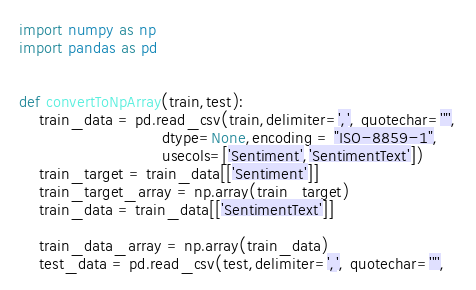<code> <loc_0><loc_0><loc_500><loc_500><_Python_>import numpy as np
import pandas as pd


def convertToNpArray(train,test):
    train_data = pd.read_csv(train,delimiter=',', quotechar='"',
                             dtype=None,encoding = "ISO-8859-1",
                             usecols=['Sentiment','SentimentText'])
    train_target = train_data[['Sentiment']]
    train_target_array = np.array(train_target)
    train_data = train_data[['SentimentText']]

    train_data_array = np.array(train_data)
    test_data = pd.read_csv(test,delimiter=',', quotechar='"',</code> 